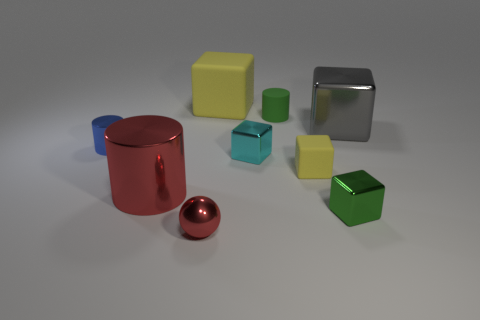What can you infer about the lighting in this scene? The lighting in the scene is soft and diffused, coming from above as indicated by the subtle shadows directly beneath the objects. The lack of harsh shadows or strong highlights suggests an environment with a strong ambient light, possibly in a studio setting. 